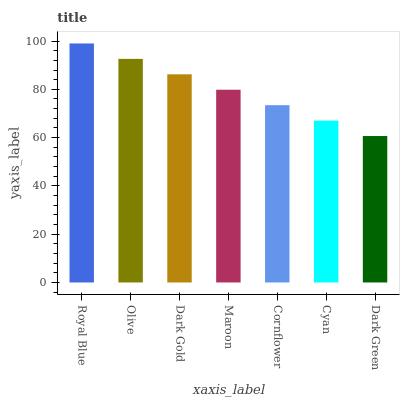Is Dark Green the minimum?
Answer yes or no. Yes. Is Royal Blue the maximum?
Answer yes or no. Yes. Is Olive the minimum?
Answer yes or no. No. Is Olive the maximum?
Answer yes or no. No. Is Royal Blue greater than Olive?
Answer yes or no. Yes. Is Olive less than Royal Blue?
Answer yes or no. Yes. Is Olive greater than Royal Blue?
Answer yes or no. No. Is Royal Blue less than Olive?
Answer yes or no. No. Is Maroon the high median?
Answer yes or no. Yes. Is Maroon the low median?
Answer yes or no. Yes. Is Olive the high median?
Answer yes or no. No. Is Cyan the low median?
Answer yes or no. No. 